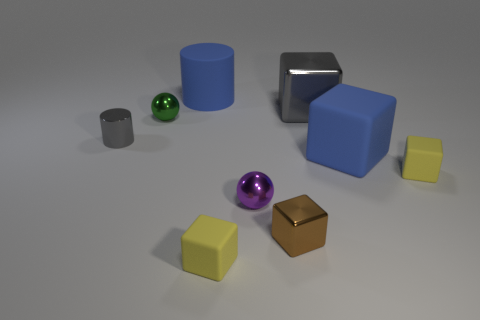Are there more purple objects that are behind the large blue rubber block than yellow things that are on the left side of the large gray thing?
Give a very brief answer. No. Does the cylinder left of the blue cylinder have the same size as the blue rubber thing that is left of the tiny purple sphere?
Provide a succinct answer. No. The tiny purple metal object has what shape?
Your response must be concise. Sphere. What size is the rubber object that is the same color as the large matte cylinder?
Ensure brevity in your answer.  Large. What is the color of the other tiny sphere that is the same material as the tiny green ball?
Give a very brief answer. Purple. Are the small gray cylinder and the large blue thing on the right side of the large gray cube made of the same material?
Keep it short and to the point. No. What color is the shiny cylinder?
Your answer should be compact. Gray. What is the size of the purple thing that is made of the same material as the tiny brown thing?
Make the answer very short. Small. How many small shiny cubes are to the left of the small green object behind the yellow rubber cube behind the brown object?
Your answer should be compact. 0. There is a small cylinder; does it have the same color as the large rubber thing to the left of the blue cube?
Offer a very short reply. No. 